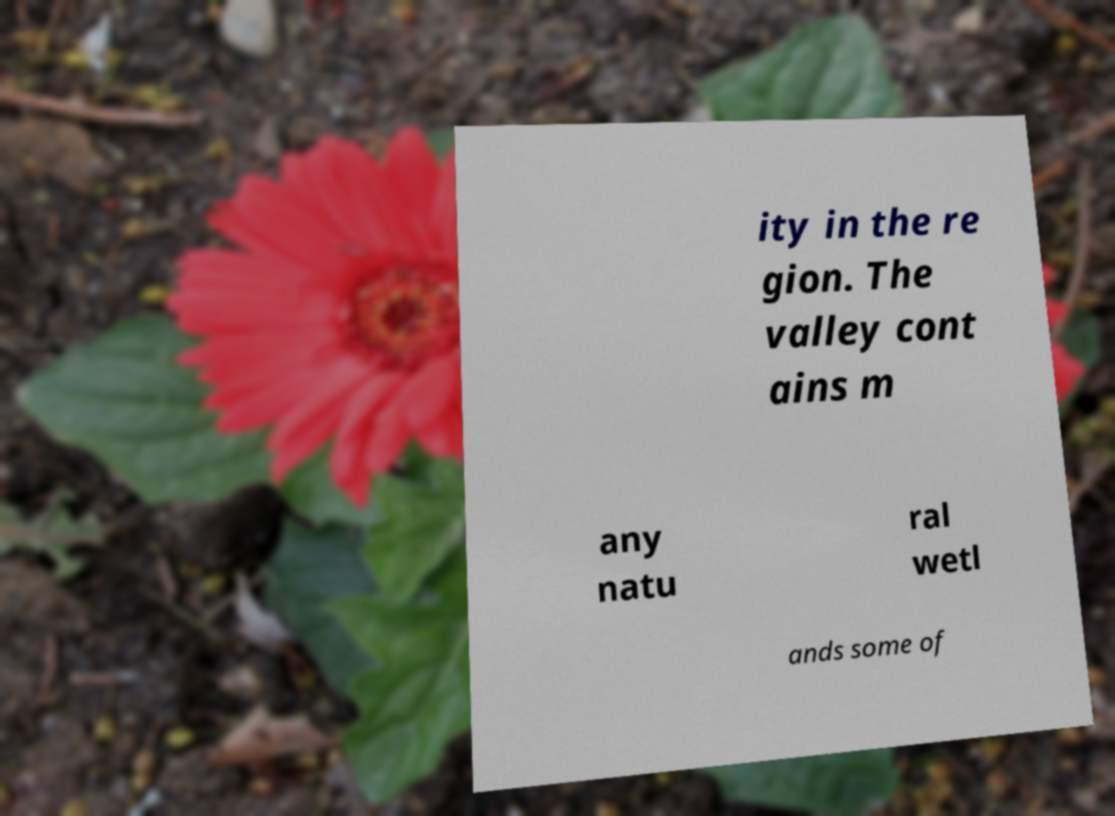Can you accurately transcribe the text from the provided image for me? ity in the re gion. The valley cont ains m any natu ral wetl ands some of 